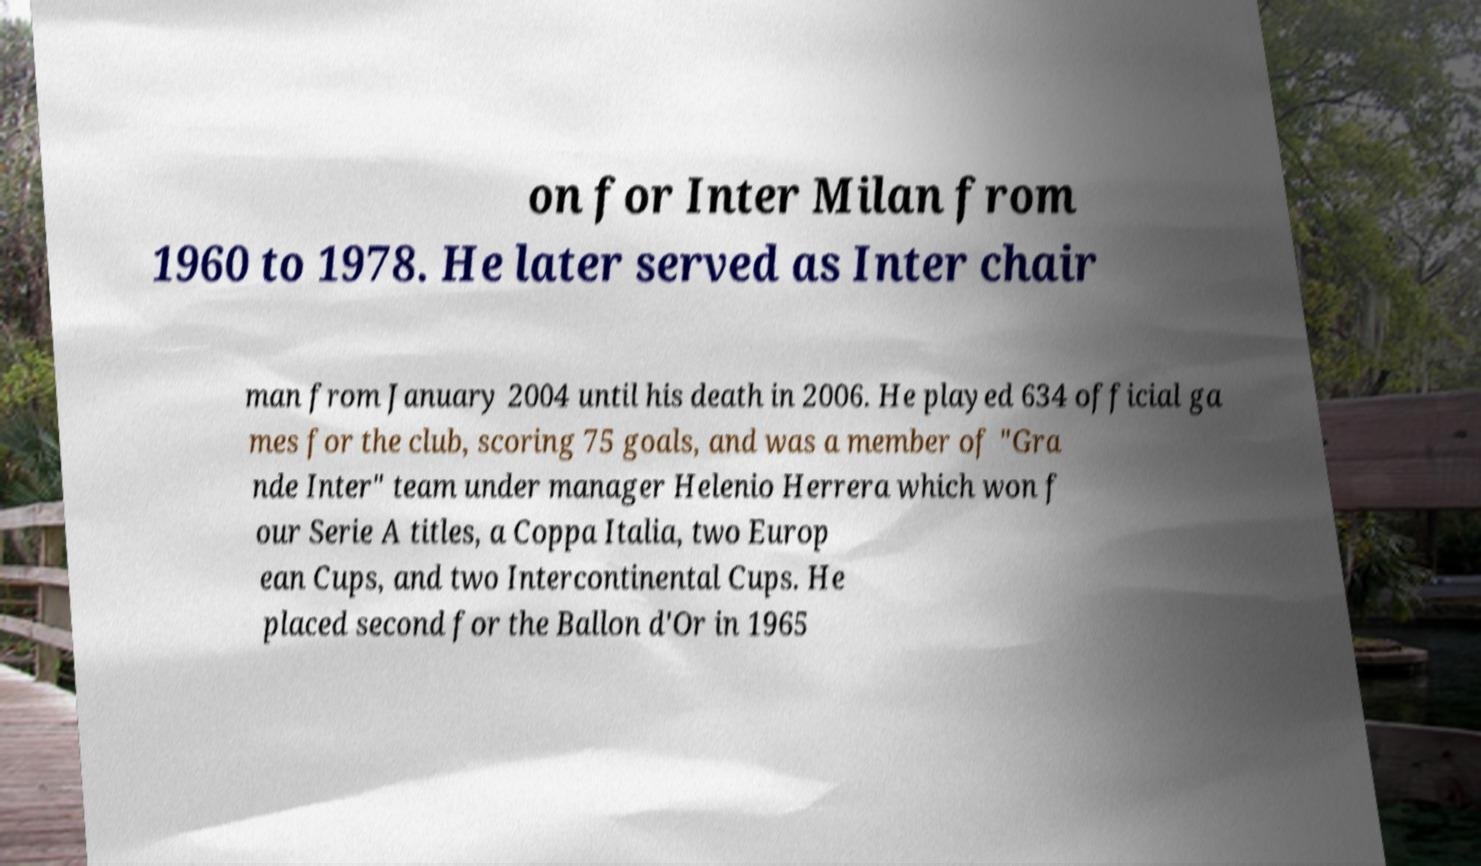Please identify and transcribe the text found in this image. on for Inter Milan from 1960 to 1978. He later served as Inter chair man from January 2004 until his death in 2006. He played 634 official ga mes for the club, scoring 75 goals, and was a member of "Gra nde Inter" team under manager Helenio Herrera which won f our Serie A titles, a Coppa Italia, two Europ ean Cups, and two Intercontinental Cups. He placed second for the Ballon d'Or in 1965 